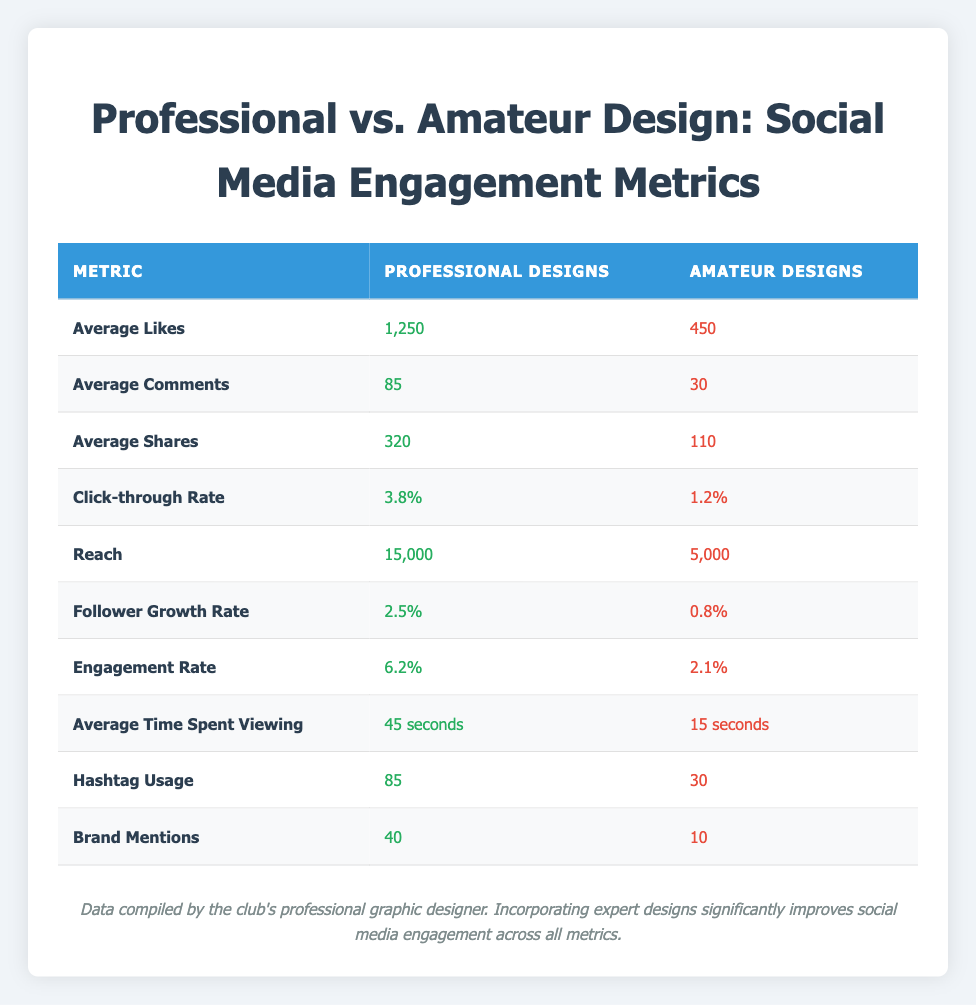What is the average number of Likes for professional designs? The table shows that the average number of Likes for professional designs is 1,250.
Answer: 1,250 What is the average number of Comments for amateur designs? The table indicates that the average number of Comments for amateur designs is 30.
Answer: 30 Is the Reach for professional designs greater than that of amateur designs? Yes, the Reach for professional designs is 15,000, which is greater than the Reach for amateur designs at 5,000.
Answer: Yes What is the difference in Average Shares between professional and amateur designs? For professional designs, the Average Shares is 320 and for amateur designs it is 110. The difference is 320 - 110 = 210.
Answer: 210 What is the Click-through Rate for professional designs? The table states that the Click-through Rate for professional designs is 3.8%.
Answer: 3.8% If we compare both Follower Growth Rates, how much more effective are professional designs compared to amateur ones? The Follower Growth Rate for professional designs is 2.5% and for amateur designs it is 0.8%. The difference is 2.5 - 0.8 = 1.7%. Thus, professional designs are 1.7% more effective.
Answer: 1.7% What are the average times spent viewing for amateur designs and how does it compare to professional designs? The average time spent viewing for amateur designs is 15 seconds and for professional designs, it is 45 seconds. This means that viewers spend 30 seconds longer on professional designs.
Answer: 30 seconds Is the Engagement Rate for amateur designs higher than the Engagement Rate for professional designs? No, the Engagement Rate for amateur designs is 2.1%, which is lower than the Engagement Rate for professional designs at 6.2%.
Answer: No What is the total number of Hashtags used in professional designs and amateur designs combined? For professional designs, Hashtag Usage is 85 and for amateur designs it is 30. The total is 85 + 30 = 115.
Answer: 115 